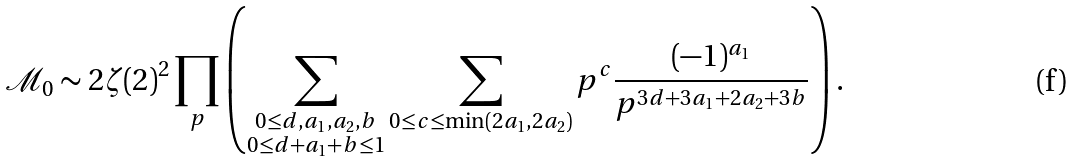Convert formula to latex. <formula><loc_0><loc_0><loc_500><loc_500>\mathcal { M } _ { 0 } \sim 2 \zeta ( 2 ) ^ { 2 } \prod _ { p } \left ( \sum _ { \substack { 0 \leq d , a _ { 1 } , a _ { 2 } , b \\ 0 \leq d + a _ { 1 } + b \leq 1 } } \sum _ { 0 \leq c \leq \min ( 2 a _ { 1 } , 2 a _ { 2 } ) } p ^ { c } \frac { ( - 1 ) ^ { a _ { 1 } } } { p ^ { 3 d + 3 a _ { 1 } + 2 a _ { 2 } + 3 b } } \right ) .</formula> 